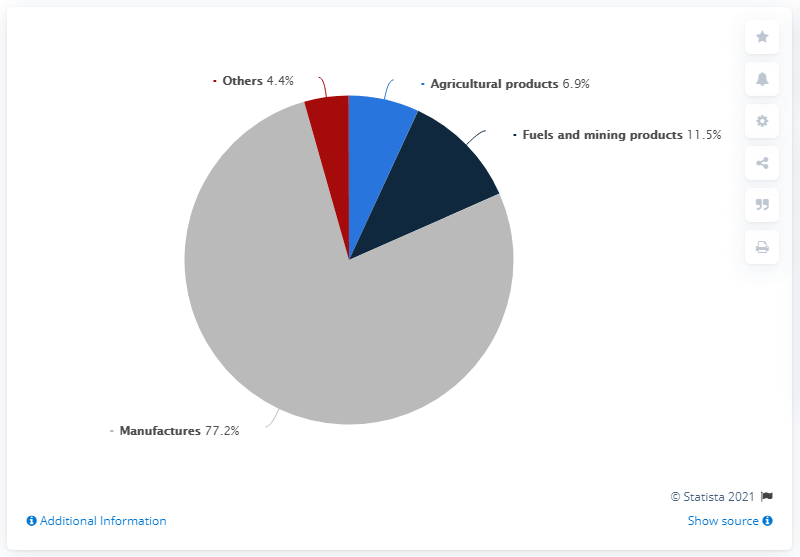Highlight a few significant elements in this photo. The total, excluding manufacturers, is 22.8. The product that is prevalent in the chart is the manufacturer. 